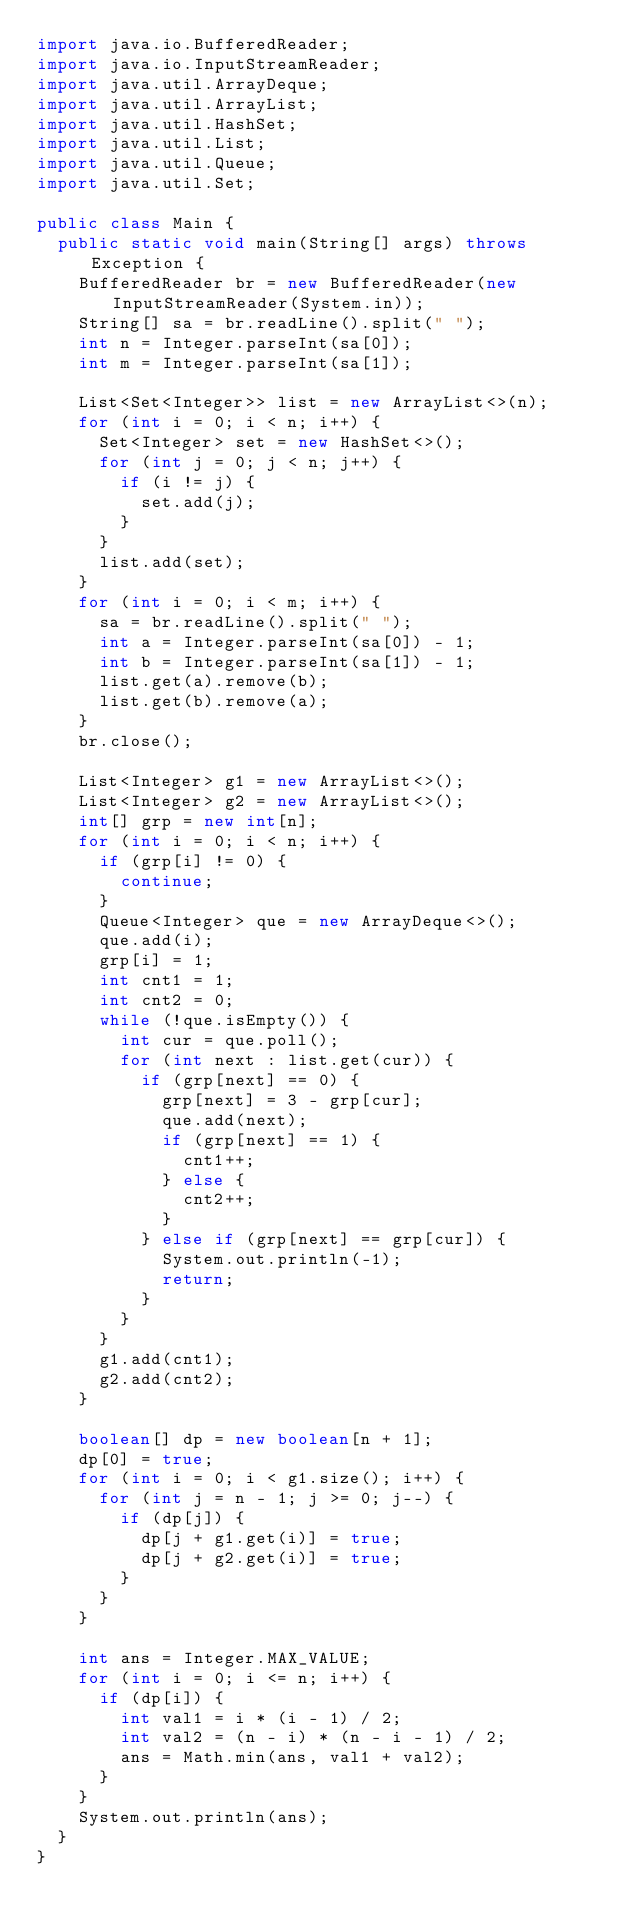<code> <loc_0><loc_0><loc_500><loc_500><_Java_>import java.io.BufferedReader;
import java.io.InputStreamReader;
import java.util.ArrayDeque;
import java.util.ArrayList;
import java.util.HashSet;
import java.util.List;
import java.util.Queue;
import java.util.Set;

public class Main {
	public static void main(String[] args) throws Exception {
		BufferedReader br = new BufferedReader(new InputStreamReader(System.in));
		String[] sa = br.readLine().split(" ");
		int n = Integer.parseInt(sa[0]);
		int m = Integer.parseInt(sa[1]);

		List<Set<Integer>> list = new ArrayList<>(n);
		for (int i = 0; i < n; i++) {
			Set<Integer> set = new HashSet<>();
			for (int j = 0; j < n; j++) {
				if (i != j) {
					set.add(j);
				}
			}
			list.add(set);
		}
		for (int i = 0; i < m; i++) {
			sa = br.readLine().split(" ");
			int a = Integer.parseInt(sa[0]) - 1;
			int b = Integer.parseInt(sa[1]) - 1;
			list.get(a).remove(b);
			list.get(b).remove(a);
		}
		br.close();

		List<Integer> g1 = new ArrayList<>();
		List<Integer> g2 = new ArrayList<>();
		int[] grp = new int[n];
		for (int i = 0; i < n; i++) {
			if (grp[i] != 0) {
				continue;
			}
			Queue<Integer> que = new ArrayDeque<>();
			que.add(i);
			grp[i] = 1;
			int cnt1 = 1;
			int cnt2 = 0;
			while (!que.isEmpty()) {
				int cur = que.poll();
				for (int next : list.get(cur)) {
					if (grp[next] == 0) {
						grp[next] = 3 - grp[cur];
						que.add(next);
						if (grp[next] == 1) {
							cnt1++;
						} else {
							cnt2++;
						}
					} else if (grp[next] == grp[cur]) {
						System.out.println(-1);
						return;
					}
				}
			}
			g1.add(cnt1);
			g2.add(cnt2);
		}

		boolean[] dp = new boolean[n + 1];
		dp[0] = true;
		for (int i = 0; i < g1.size(); i++) {
			for (int j = n - 1; j >= 0; j--) {
				if (dp[j]) {
					dp[j + g1.get(i)] = true;
					dp[j + g2.get(i)] = true;
				}
			}
		}

		int ans = Integer.MAX_VALUE;
		for (int i = 0; i <= n; i++) {
			if (dp[i]) {
				int val1 = i * (i - 1) / 2;
				int val2 = (n - i) * (n - i - 1) / 2;
				ans = Math.min(ans, val1 + val2);
			}
		}
		System.out.println(ans);
	}
}
</code> 